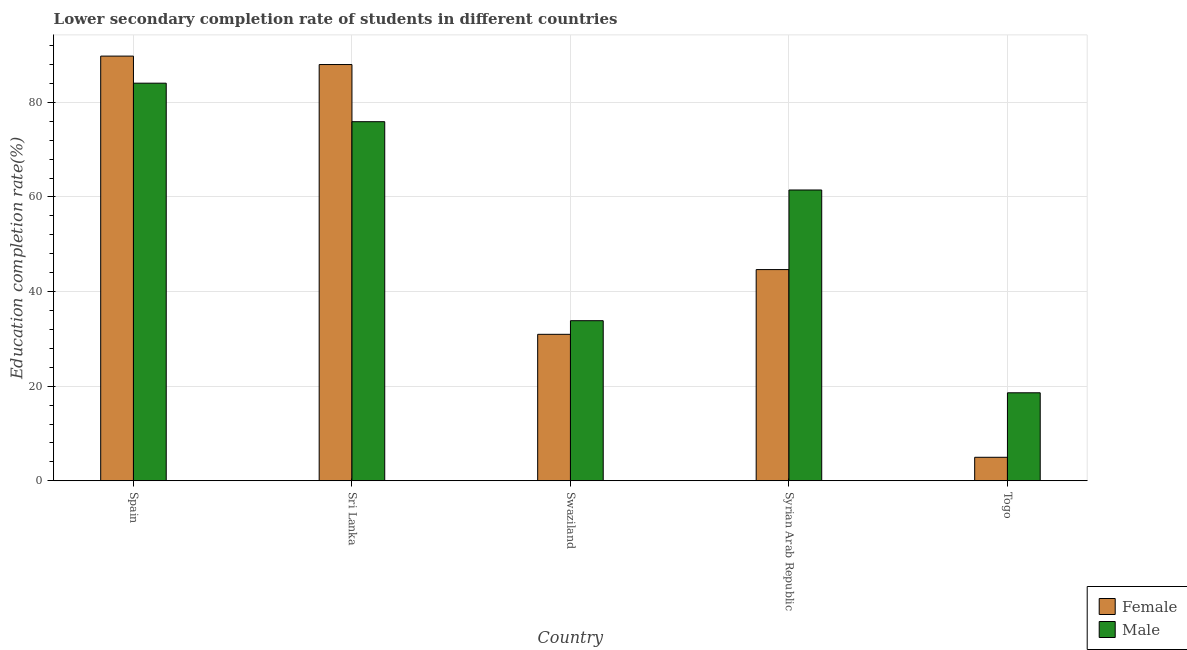How many different coloured bars are there?
Your response must be concise. 2. Are the number of bars on each tick of the X-axis equal?
Give a very brief answer. Yes. How many bars are there on the 2nd tick from the left?
Your response must be concise. 2. What is the label of the 3rd group of bars from the left?
Your answer should be very brief. Swaziland. What is the education completion rate of male students in Swaziland?
Ensure brevity in your answer.  33.84. Across all countries, what is the maximum education completion rate of female students?
Make the answer very short. 89.77. Across all countries, what is the minimum education completion rate of male students?
Your response must be concise. 18.6. In which country was the education completion rate of male students maximum?
Provide a short and direct response. Spain. In which country was the education completion rate of male students minimum?
Give a very brief answer. Togo. What is the total education completion rate of male students in the graph?
Give a very brief answer. 273.88. What is the difference between the education completion rate of female students in Spain and that in Swaziland?
Make the answer very short. 58.81. What is the difference between the education completion rate of male students in Syrian Arab Republic and the education completion rate of female students in Sri Lanka?
Your response must be concise. -26.52. What is the average education completion rate of female students per country?
Your answer should be very brief. 51.67. What is the difference between the education completion rate of female students and education completion rate of male students in Togo?
Make the answer very short. -13.63. What is the ratio of the education completion rate of female students in Sri Lanka to that in Togo?
Ensure brevity in your answer.  17.72. Is the education completion rate of female students in Sri Lanka less than that in Syrian Arab Republic?
Give a very brief answer. No. What is the difference between the highest and the second highest education completion rate of female students?
Offer a very short reply. 1.78. What is the difference between the highest and the lowest education completion rate of female students?
Make the answer very short. 84.81. Is the sum of the education completion rate of male students in Syrian Arab Republic and Togo greater than the maximum education completion rate of female students across all countries?
Your answer should be very brief. No. What does the 2nd bar from the left in Sri Lanka represents?
Keep it short and to the point. Male. What does the 1st bar from the right in Spain represents?
Your answer should be compact. Male. How many bars are there?
Provide a succinct answer. 10. Are the values on the major ticks of Y-axis written in scientific E-notation?
Provide a short and direct response. No. Does the graph contain any zero values?
Offer a very short reply. No. How are the legend labels stacked?
Your answer should be compact. Vertical. What is the title of the graph?
Offer a very short reply. Lower secondary completion rate of students in different countries. Does "State government" appear as one of the legend labels in the graph?
Offer a very short reply. No. What is the label or title of the Y-axis?
Make the answer very short. Education completion rate(%). What is the Education completion rate(%) of Female in Spain?
Provide a succinct answer. 89.77. What is the Education completion rate(%) in Male in Spain?
Your answer should be very brief. 84.05. What is the Education completion rate(%) in Female in Sri Lanka?
Ensure brevity in your answer.  87.99. What is the Education completion rate(%) in Male in Sri Lanka?
Provide a short and direct response. 75.91. What is the Education completion rate(%) of Female in Swaziland?
Provide a short and direct response. 30.96. What is the Education completion rate(%) of Male in Swaziland?
Provide a short and direct response. 33.84. What is the Education completion rate(%) in Female in Syrian Arab Republic?
Make the answer very short. 44.65. What is the Education completion rate(%) in Male in Syrian Arab Republic?
Your answer should be very brief. 61.47. What is the Education completion rate(%) in Female in Togo?
Provide a succinct answer. 4.97. What is the Education completion rate(%) of Male in Togo?
Ensure brevity in your answer.  18.6. Across all countries, what is the maximum Education completion rate(%) in Female?
Your answer should be very brief. 89.77. Across all countries, what is the maximum Education completion rate(%) in Male?
Provide a succinct answer. 84.05. Across all countries, what is the minimum Education completion rate(%) in Female?
Give a very brief answer. 4.97. Across all countries, what is the minimum Education completion rate(%) in Male?
Provide a succinct answer. 18.6. What is the total Education completion rate(%) of Female in the graph?
Offer a very short reply. 258.34. What is the total Education completion rate(%) of Male in the graph?
Your answer should be very brief. 273.88. What is the difference between the Education completion rate(%) of Female in Spain and that in Sri Lanka?
Keep it short and to the point. 1.78. What is the difference between the Education completion rate(%) of Male in Spain and that in Sri Lanka?
Your answer should be compact. 8.14. What is the difference between the Education completion rate(%) in Female in Spain and that in Swaziland?
Offer a terse response. 58.81. What is the difference between the Education completion rate(%) of Male in Spain and that in Swaziland?
Your response must be concise. 50.21. What is the difference between the Education completion rate(%) in Female in Spain and that in Syrian Arab Republic?
Provide a succinct answer. 45.13. What is the difference between the Education completion rate(%) in Male in Spain and that in Syrian Arab Republic?
Your answer should be very brief. 22.58. What is the difference between the Education completion rate(%) of Female in Spain and that in Togo?
Offer a terse response. 84.81. What is the difference between the Education completion rate(%) in Male in Spain and that in Togo?
Offer a terse response. 65.45. What is the difference between the Education completion rate(%) in Female in Sri Lanka and that in Swaziland?
Offer a very short reply. 57.03. What is the difference between the Education completion rate(%) of Male in Sri Lanka and that in Swaziland?
Give a very brief answer. 42.07. What is the difference between the Education completion rate(%) in Female in Sri Lanka and that in Syrian Arab Republic?
Your answer should be very brief. 43.35. What is the difference between the Education completion rate(%) in Male in Sri Lanka and that in Syrian Arab Republic?
Your response must be concise. 14.44. What is the difference between the Education completion rate(%) in Female in Sri Lanka and that in Togo?
Your answer should be very brief. 83.03. What is the difference between the Education completion rate(%) of Male in Sri Lanka and that in Togo?
Your response must be concise. 57.31. What is the difference between the Education completion rate(%) of Female in Swaziland and that in Syrian Arab Republic?
Offer a very short reply. -13.69. What is the difference between the Education completion rate(%) of Male in Swaziland and that in Syrian Arab Republic?
Provide a short and direct response. -27.63. What is the difference between the Education completion rate(%) in Female in Swaziland and that in Togo?
Your answer should be compact. 26. What is the difference between the Education completion rate(%) of Male in Swaziland and that in Togo?
Offer a terse response. 15.24. What is the difference between the Education completion rate(%) of Female in Syrian Arab Republic and that in Togo?
Make the answer very short. 39.68. What is the difference between the Education completion rate(%) of Male in Syrian Arab Republic and that in Togo?
Make the answer very short. 42.87. What is the difference between the Education completion rate(%) in Female in Spain and the Education completion rate(%) in Male in Sri Lanka?
Your response must be concise. 13.86. What is the difference between the Education completion rate(%) in Female in Spain and the Education completion rate(%) in Male in Swaziland?
Provide a succinct answer. 55.93. What is the difference between the Education completion rate(%) of Female in Spain and the Education completion rate(%) of Male in Syrian Arab Republic?
Provide a short and direct response. 28.3. What is the difference between the Education completion rate(%) of Female in Spain and the Education completion rate(%) of Male in Togo?
Give a very brief answer. 71.17. What is the difference between the Education completion rate(%) of Female in Sri Lanka and the Education completion rate(%) of Male in Swaziland?
Make the answer very short. 54.15. What is the difference between the Education completion rate(%) of Female in Sri Lanka and the Education completion rate(%) of Male in Syrian Arab Republic?
Give a very brief answer. 26.52. What is the difference between the Education completion rate(%) of Female in Sri Lanka and the Education completion rate(%) of Male in Togo?
Give a very brief answer. 69.39. What is the difference between the Education completion rate(%) in Female in Swaziland and the Education completion rate(%) in Male in Syrian Arab Republic?
Offer a terse response. -30.51. What is the difference between the Education completion rate(%) in Female in Swaziland and the Education completion rate(%) in Male in Togo?
Give a very brief answer. 12.36. What is the difference between the Education completion rate(%) of Female in Syrian Arab Republic and the Education completion rate(%) of Male in Togo?
Provide a short and direct response. 26.05. What is the average Education completion rate(%) of Female per country?
Your response must be concise. 51.67. What is the average Education completion rate(%) of Male per country?
Your answer should be very brief. 54.78. What is the difference between the Education completion rate(%) of Female and Education completion rate(%) of Male in Spain?
Give a very brief answer. 5.72. What is the difference between the Education completion rate(%) in Female and Education completion rate(%) in Male in Sri Lanka?
Provide a short and direct response. 12.08. What is the difference between the Education completion rate(%) of Female and Education completion rate(%) of Male in Swaziland?
Keep it short and to the point. -2.88. What is the difference between the Education completion rate(%) in Female and Education completion rate(%) in Male in Syrian Arab Republic?
Ensure brevity in your answer.  -16.83. What is the difference between the Education completion rate(%) in Female and Education completion rate(%) in Male in Togo?
Your answer should be very brief. -13.63. What is the ratio of the Education completion rate(%) of Female in Spain to that in Sri Lanka?
Your response must be concise. 1.02. What is the ratio of the Education completion rate(%) in Male in Spain to that in Sri Lanka?
Ensure brevity in your answer.  1.11. What is the ratio of the Education completion rate(%) of Female in Spain to that in Swaziland?
Offer a terse response. 2.9. What is the ratio of the Education completion rate(%) of Male in Spain to that in Swaziland?
Your answer should be compact. 2.48. What is the ratio of the Education completion rate(%) in Female in Spain to that in Syrian Arab Republic?
Offer a very short reply. 2.01. What is the ratio of the Education completion rate(%) in Male in Spain to that in Syrian Arab Republic?
Ensure brevity in your answer.  1.37. What is the ratio of the Education completion rate(%) in Female in Spain to that in Togo?
Give a very brief answer. 18.08. What is the ratio of the Education completion rate(%) of Male in Spain to that in Togo?
Your answer should be very brief. 4.52. What is the ratio of the Education completion rate(%) in Female in Sri Lanka to that in Swaziland?
Your answer should be very brief. 2.84. What is the ratio of the Education completion rate(%) in Male in Sri Lanka to that in Swaziland?
Offer a very short reply. 2.24. What is the ratio of the Education completion rate(%) of Female in Sri Lanka to that in Syrian Arab Republic?
Offer a very short reply. 1.97. What is the ratio of the Education completion rate(%) of Male in Sri Lanka to that in Syrian Arab Republic?
Ensure brevity in your answer.  1.23. What is the ratio of the Education completion rate(%) in Female in Sri Lanka to that in Togo?
Provide a succinct answer. 17.72. What is the ratio of the Education completion rate(%) of Male in Sri Lanka to that in Togo?
Provide a succinct answer. 4.08. What is the ratio of the Education completion rate(%) of Female in Swaziland to that in Syrian Arab Republic?
Offer a very short reply. 0.69. What is the ratio of the Education completion rate(%) of Male in Swaziland to that in Syrian Arab Republic?
Make the answer very short. 0.55. What is the ratio of the Education completion rate(%) in Female in Swaziland to that in Togo?
Provide a short and direct response. 6.23. What is the ratio of the Education completion rate(%) of Male in Swaziland to that in Togo?
Your response must be concise. 1.82. What is the ratio of the Education completion rate(%) of Female in Syrian Arab Republic to that in Togo?
Your answer should be very brief. 8.99. What is the ratio of the Education completion rate(%) in Male in Syrian Arab Republic to that in Togo?
Keep it short and to the point. 3.3. What is the difference between the highest and the second highest Education completion rate(%) of Female?
Keep it short and to the point. 1.78. What is the difference between the highest and the second highest Education completion rate(%) of Male?
Make the answer very short. 8.14. What is the difference between the highest and the lowest Education completion rate(%) of Female?
Make the answer very short. 84.81. What is the difference between the highest and the lowest Education completion rate(%) of Male?
Provide a short and direct response. 65.45. 